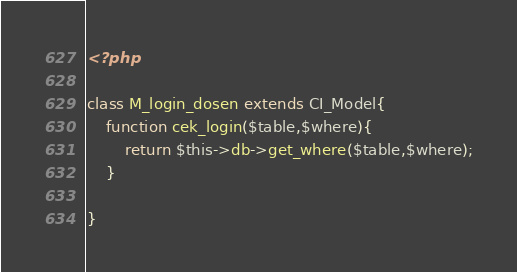<code> <loc_0><loc_0><loc_500><loc_500><_PHP_><?php 
 
class M_login_dosen extends CI_Model{	
	function cek_login($table,$where){		
		return $this->db->get_where($table,$where);
	}
	
}</code> 